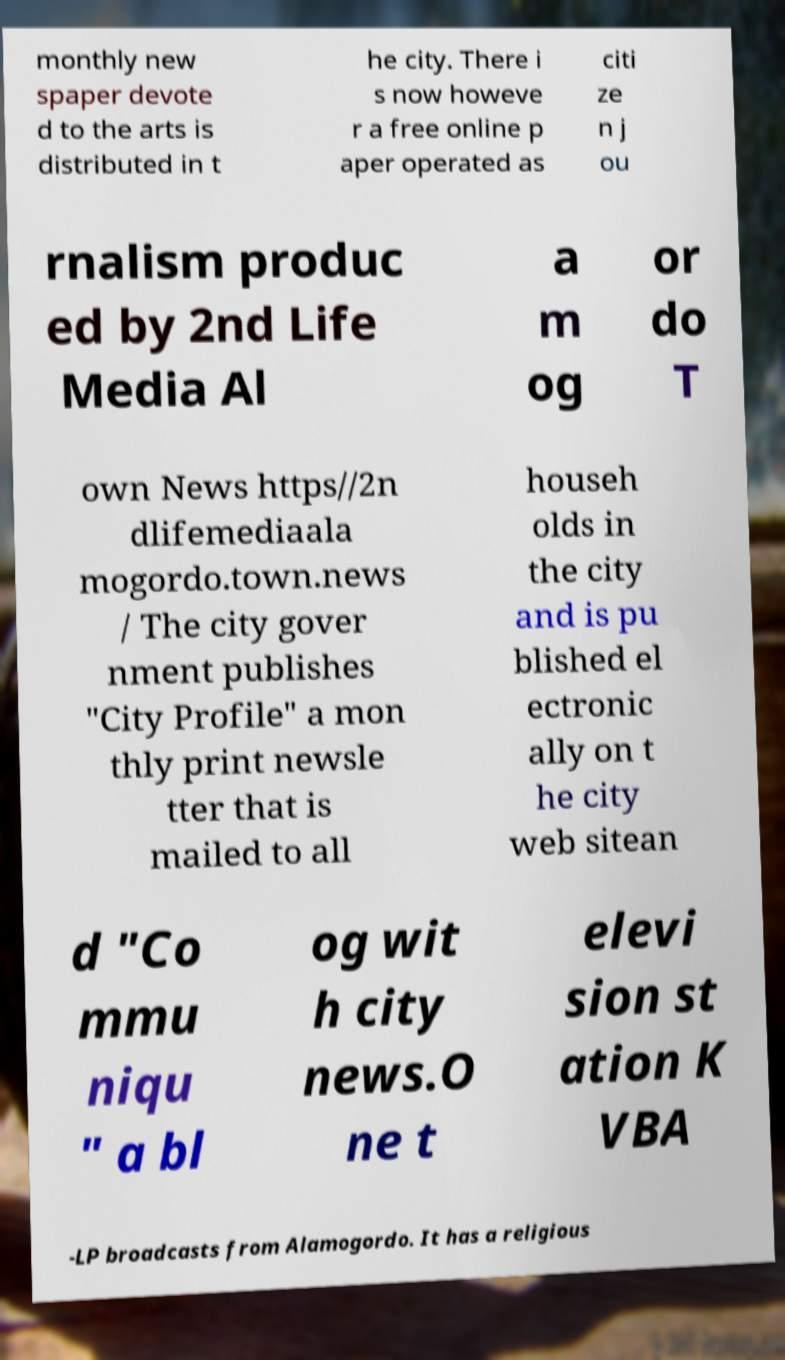Please identify and transcribe the text found in this image. monthly new spaper devote d to the arts is distributed in t he city. There i s now howeve r a free online p aper operated as citi ze n j ou rnalism produc ed by 2nd Life Media Al a m og or do T own News https//2n dlifemediaala mogordo.town.news / The city gover nment publishes "City Profile" a mon thly print newsle tter that is mailed to all househ olds in the city and is pu blished el ectronic ally on t he city web sitean d "Co mmu niqu " a bl og wit h city news.O ne t elevi sion st ation K VBA -LP broadcasts from Alamogordo. It has a religious 